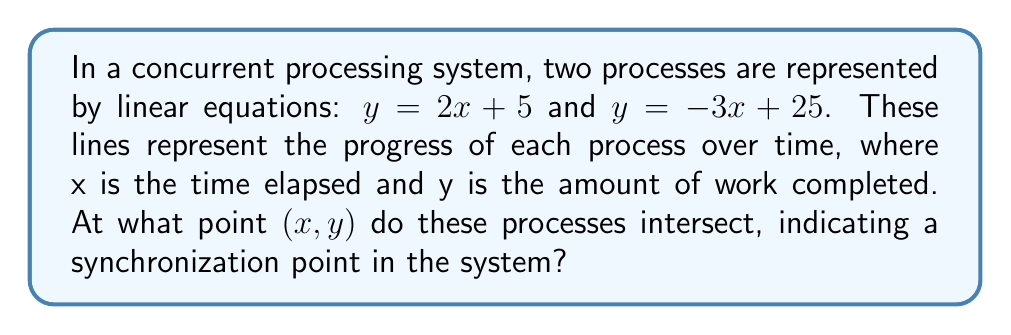What is the answer to this math problem? To find the intersection point of two lines, we need to solve the system of equations:

$$\begin{cases}
y = 2x + 5 \\
y = -3x + 25
\end{cases}$$

Step 1: Set the equations equal to each other since they intersect at a common point.
$2x + 5 = -3x + 25$

Step 2: Solve for x by isolating variables on one side and constants on the other.
$2x + 3x = 25 - 5$
$5x = 20$

Step 3: Divide both sides by 5 to find x.
$x = 4$

Step 4: Substitute x = 4 into either of the original equations to find y. Let's use the first equation:
$y = 2(4) + 5$
$y = 8 + 5 = 13$

Therefore, the intersection point is (4, 13).

In the context of concurrent processes, this means the two processes synchronize after 4 time units, having completed 13 units of work.
Answer: (4, 13) 